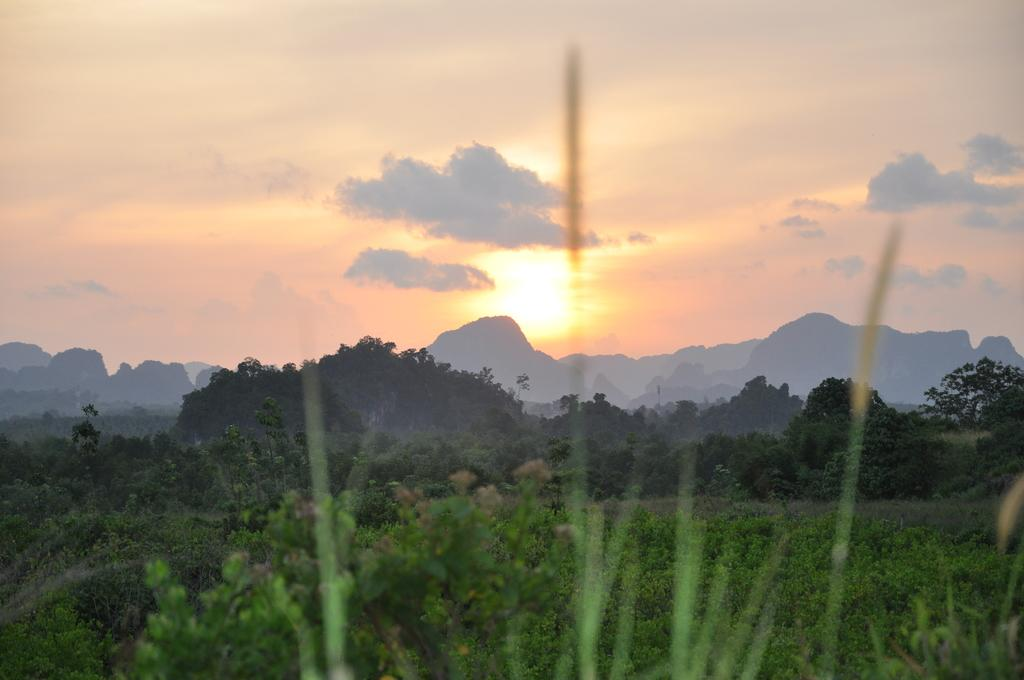What type of vegetation can be seen in the image? There are plants in the image. What can be seen in the background of the image? There are trees and mountains in the background of the image. What part of the natural environment is visible in the image? The sky is visible in the background of the image. Where is the door located in the image? There is no door present in the image. Can you describe the end of the image? The image does not have an end, as it is a two-dimensional representation. 